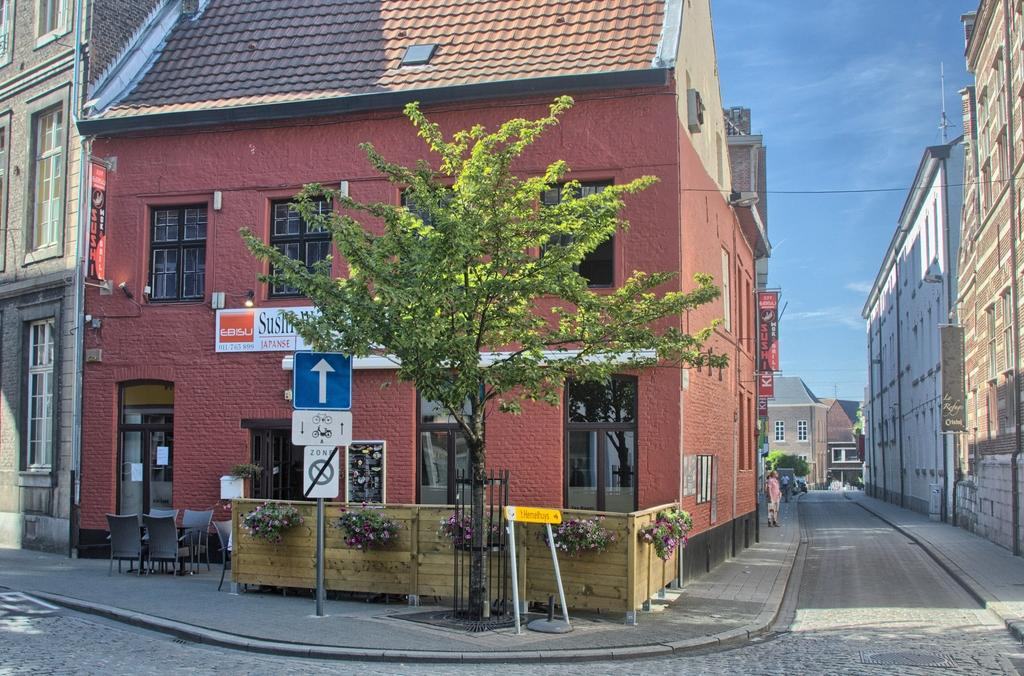What type of structures can be seen in the image? There are buildings in the image. What else is present in the image besides buildings? There are plants, boards with text, and a fence in the image. Can you describe the person in the image? There is a person standing on the road in the image. How does the jellyfish interact with the person standing on the road in the image? There is no jellyfish present in the image, so it cannot interact with the person standing on the road. 